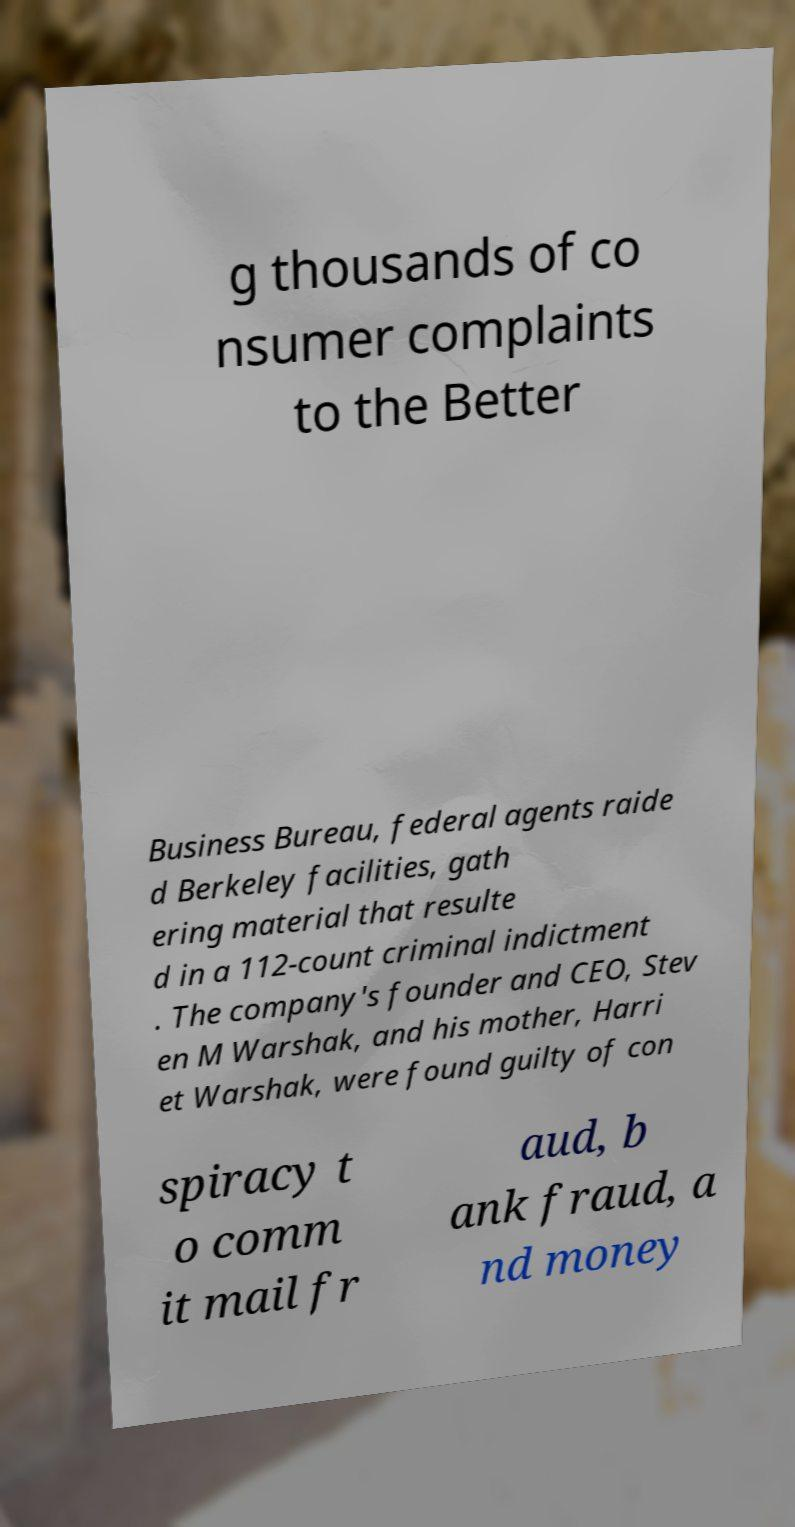Can you accurately transcribe the text from the provided image for me? g thousands of co nsumer complaints to the Better Business Bureau, federal agents raide d Berkeley facilities, gath ering material that resulte d in a 112-count criminal indictment . The company's founder and CEO, Stev en M Warshak, and his mother, Harri et Warshak, were found guilty of con spiracy t o comm it mail fr aud, b ank fraud, a nd money 